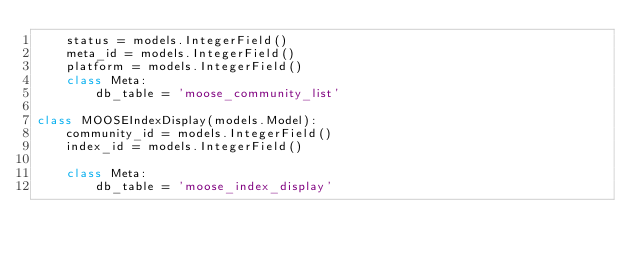<code> <loc_0><loc_0><loc_500><loc_500><_Python_>    status = models.IntegerField()
    meta_id = models.IntegerField()
    platform = models.IntegerField()
    class Meta:
        db_table = 'moose_community_list'

class MOOSEIndexDisplay(models.Model):
    community_id = models.IntegerField()
    index_id = models.IntegerField()

    class Meta:
        db_table = 'moose_index_display'</code> 